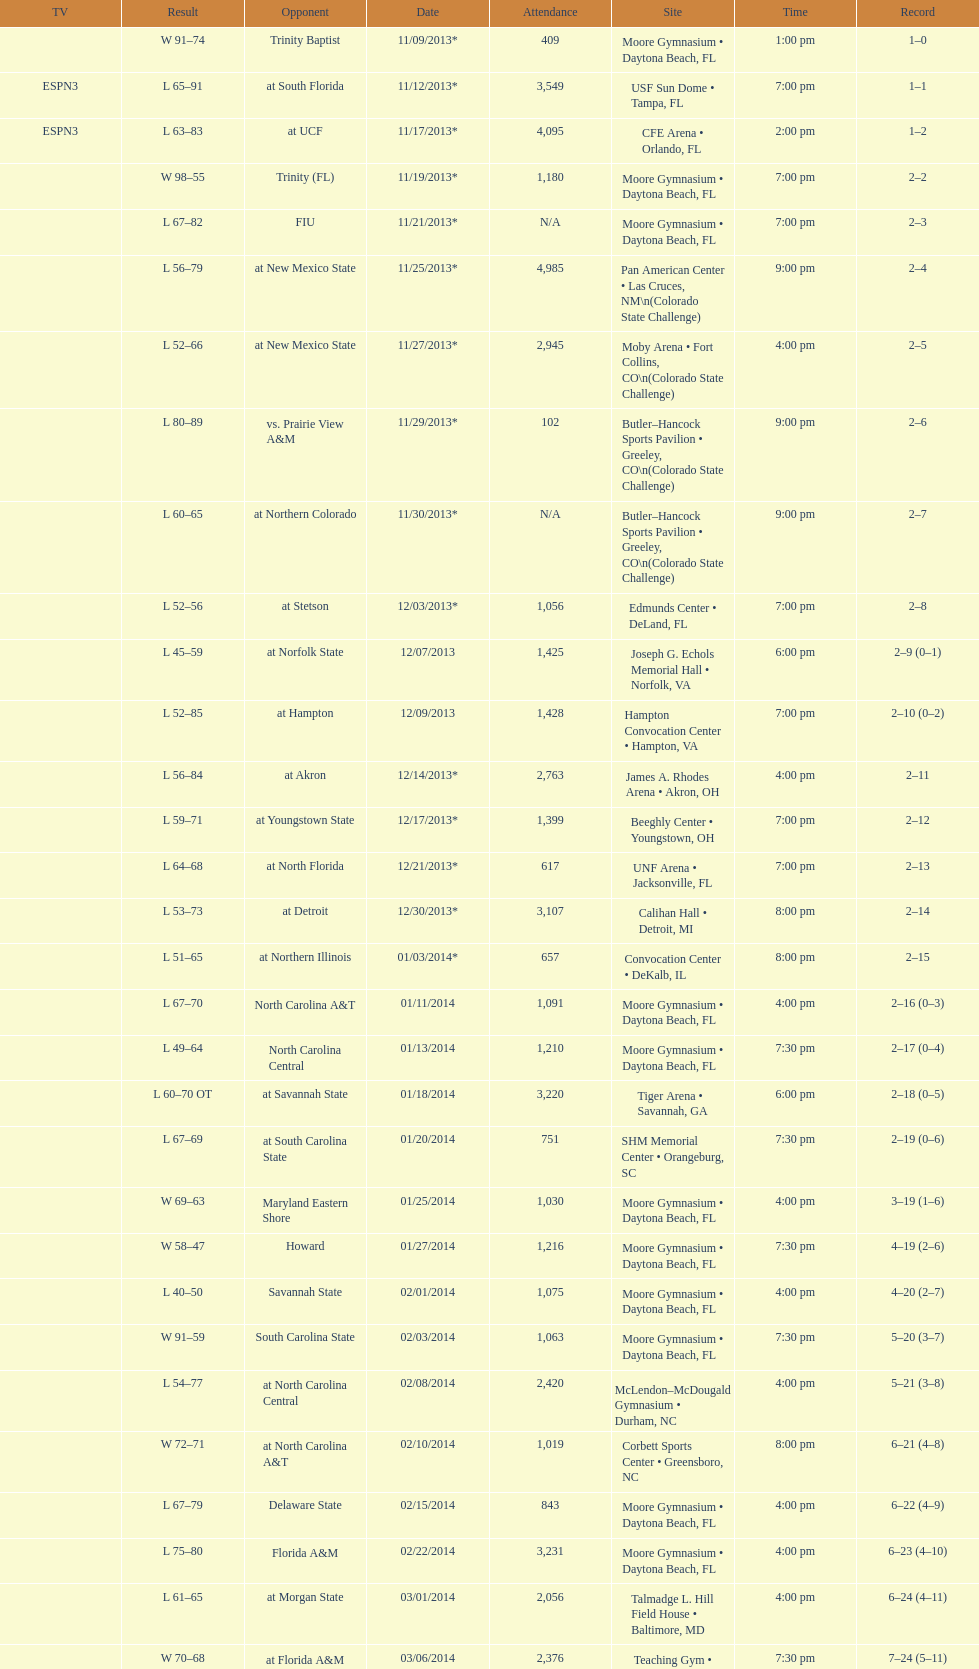Which game occurred later in the evening, fiu or northern colorado? Northern Colorado. 